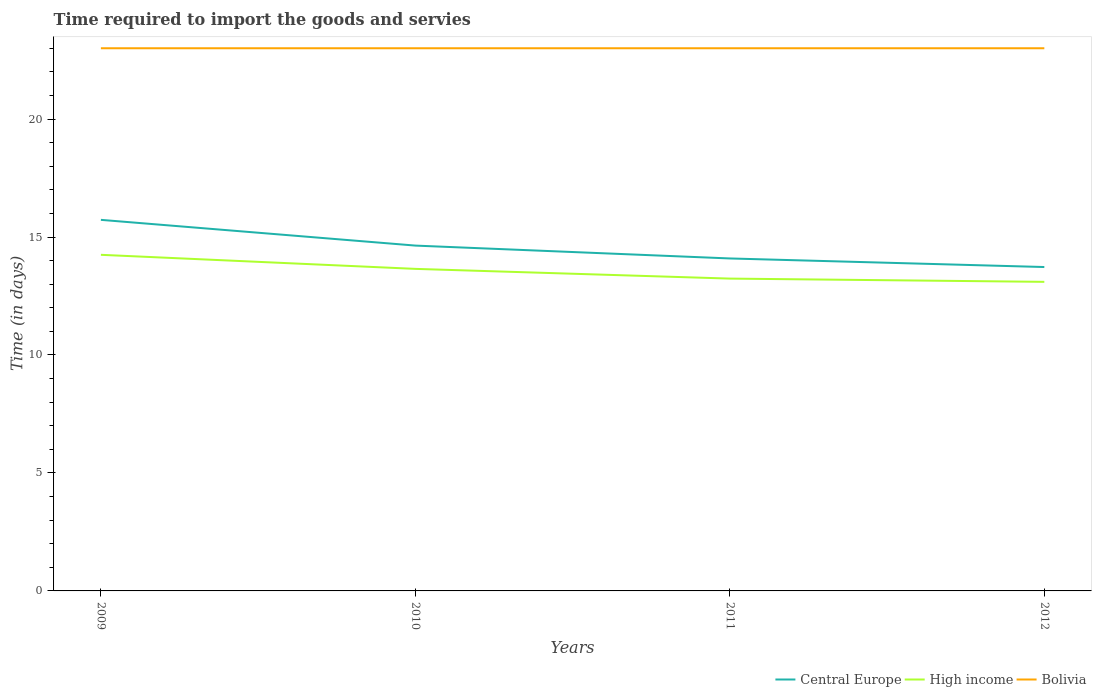How many different coloured lines are there?
Provide a short and direct response. 3. Does the line corresponding to Bolivia intersect with the line corresponding to High income?
Your answer should be compact. No. Across all years, what is the maximum number of days required to import the goods and services in Bolivia?
Make the answer very short. 23. In which year was the number of days required to import the goods and services in Bolivia maximum?
Keep it short and to the point. 2009. What is the total number of days required to import the goods and services in Central Europe in the graph?
Your response must be concise. 1.09. What is the difference between the highest and the second highest number of days required to import the goods and services in Bolivia?
Offer a very short reply. 0. How many years are there in the graph?
Offer a very short reply. 4. Are the values on the major ticks of Y-axis written in scientific E-notation?
Make the answer very short. No. Does the graph contain grids?
Offer a terse response. No. Where does the legend appear in the graph?
Give a very brief answer. Bottom right. How many legend labels are there?
Offer a very short reply. 3. How are the legend labels stacked?
Offer a terse response. Horizontal. What is the title of the graph?
Your answer should be very brief. Time required to import the goods and servies. Does "Malta" appear as one of the legend labels in the graph?
Offer a very short reply. No. What is the label or title of the X-axis?
Offer a very short reply. Years. What is the label or title of the Y-axis?
Your answer should be compact. Time (in days). What is the Time (in days) of Central Europe in 2009?
Provide a short and direct response. 15.73. What is the Time (in days) in High income in 2009?
Provide a short and direct response. 14.25. What is the Time (in days) in Central Europe in 2010?
Provide a succinct answer. 14.64. What is the Time (in days) in High income in 2010?
Your response must be concise. 13.65. What is the Time (in days) of Bolivia in 2010?
Offer a terse response. 23. What is the Time (in days) of Central Europe in 2011?
Your response must be concise. 14.09. What is the Time (in days) in High income in 2011?
Give a very brief answer. 13.24. What is the Time (in days) in Central Europe in 2012?
Offer a very short reply. 13.73. What is the Time (in days) in High income in 2012?
Keep it short and to the point. 13.1. What is the Time (in days) in Bolivia in 2012?
Keep it short and to the point. 23. Across all years, what is the maximum Time (in days) of Central Europe?
Give a very brief answer. 15.73. Across all years, what is the maximum Time (in days) of High income?
Provide a succinct answer. 14.25. Across all years, what is the minimum Time (in days) in Central Europe?
Offer a very short reply. 13.73. Across all years, what is the minimum Time (in days) of Bolivia?
Your answer should be compact. 23. What is the total Time (in days) in Central Europe in the graph?
Give a very brief answer. 58.18. What is the total Time (in days) in High income in the graph?
Make the answer very short. 54.23. What is the total Time (in days) in Bolivia in the graph?
Give a very brief answer. 92. What is the difference between the Time (in days) in Central Europe in 2009 and that in 2010?
Make the answer very short. 1.09. What is the difference between the Time (in days) of High income in 2009 and that in 2010?
Give a very brief answer. 0.6. What is the difference between the Time (in days) in Central Europe in 2009 and that in 2011?
Your answer should be very brief. 1.64. What is the difference between the Time (in days) in High income in 2009 and that in 2011?
Your response must be concise. 1.01. What is the difference between the Time (in days) of High income in 2009 and that in 2012?
Your response must be concise. 1.15. What is the difference between the Time (in days) in Central Europe in 2010 and that in 2011?
Provide a short and direct response. 0.55. What is the difference between the Time (in days) of High income in 2010 and that in 2011?
Keep it short and to the point. 0.41. What is the difference between the Time (in days) of High income in 2010 and that in 2012?
Offer a very short reply. 0.55. What is the difference between the Time (in days) of Central Europe in 2011 and that in 2012?
Ensure brevity in your answer.  0.36. What is the difference between the Time (in days) in High income in 2011 and that in 2012?
Give a very brief answer. 0.14. What is the difference between the Time (in days) of Central Europe in 2009 and the Time (in days) of High income in 2010?
Your answer should be compact. 2.08. What is the difference between the Time (in days) of Central Europe in 2009 and the Time (in days) of Bolivia in 2010?
Offer a terse response. -7.27. What is the difference between the Time (in days) of High income in 2009 and the Time (in days) of Bolivia in 2010?
Offer a very short reply. -8.75. What is the difference between the Time (in days) of Central Europe in 2009 and the Time (in days) of High income in 2011?
Your answer should be compact. 2.49. What is the difference between the Time (in days) in Central Europe in 2009 and the Time (in days) in Bolivia in 2011?
Your response must be concise. -7.27. What is the difference between the Time (in days) of High income in 2009 and the Time (in days) of Bolivia in 2011?
Your answer should be compact. -8.75. What is the difference between the Time (in days) in Central Europe in 2009 and the Time (in days) in High income in 2012?
Give a very brief answer. 2.63. What is the difference between the Time (in days) of Central Europe in 2009 and the Time (in days) of Bolivia in 2012?
Provide a succinct answer. -7.27. What is the difference between the Time (in days) of High income in 2009 and the Time (in days) of Bolivia in 2012?
Offer a terse response. -8.75. What is the difference between the Time (in days) of Central Europe in 2010 and the Time (in days) of High income in 2011?
Your response must be concise. 1.4. What is the difference between the Time (in days) in Central Europe in 2010 and the Time (in days) in Bolivia in 2011?
Offer a very short reply. -8.36. What is the difference between the Time (in days) in High income in 2010 and the Time (in days) in Bolivia in 2011?
Offer a very short reply. -9.35. What is the difference between the Time (in days) in Central Europe in 2010 and the Time (in days) in High income in 2012?
Provide a short and direct response. 1.54. What is the difference between the Time (in days) in Central Europe in 2010 and the Time (in days) in Bolivia in 2012?
Your answer should be very brief. -8.36. What is the difference between the Time (in days) in High income in 2010 and the Time (in days) in Bolivia in 2012?
Your response must be concise. -9.35. What is the difference between the Time (in days) in Central Europe in 2011 and the Time (in days) in High income in 2012?
Your answer should be compact. 0.99. What is the difference between the Time (in days) in Central Europe in 2011 and the Time (in days) in Bolivia in 2012?
Ensure brevity in your answer.  -8.91. What is the difference between the Time (in days) in High income in 2011 and the Time (in days) in Bolivia in 2012?
Offer a terse response. -9.76. What is the average Time (in days) in Central Europe per year?
Make the answer very short. 14.55. What is the average Time (in days) of High income per year?
Your answer should be compact. 13.56. What is the average Time (in days) of Bolivia per year?
Provide a succinct answer. 23. In the year 2009, what is the difference between the Time (in days) in Central Europe and Time (in days) in High income?
Provide a short and direct response. 1.48. In the year 2009, what is the difference between the Time (in days) in Central Europe and Time (in days) in Bolivia?
Your response must be concise. -7.27. In the year 2009, what is the difference between the Time (in days) of High income and Time (in days) of Bolivia?
Make the answer very short. -8.75. In the year 2010, what is the difference between the Time (in days) in Central Europe and Time (in days) in High income?
Your answer should be very brief. 0.99. In the year 2010, what is the difference between the Time (in days) of Central Europe and Time (in days) of Bolivia?
Make the answer very short. -8.36. In the year 2010, what is the difference between the Time (in days) in High income and Time (in days) in Bolivia?
Your response must be concise. -9.35. In the year 2011, what is the difference between the Time (in days) in Central Europe and Time (in days) in High income?
Your answer should be compact. 0.85. In the year 2011, what is the difference between the Time (in days) of Central Europe and Time (in days) of Bolivia?
Keep it short and to the point. -8.91. In the year 2011, what is the difference between the Time (in days) of High income and Time (in days) of Bolivia?
Provide a succinct answer. -9.76. In the year 2012, what is the difference between the Time (in days) of Central Europe and Time (in days) of High income?
Ensure brevity in your answer.  0.63. In the year 2012, what is the difference between the Time (in days) in Central Europe and Time (in days) in Bolivia?
Offer a very short reply. -9.27. What is the ratio of the Time (in days) of Central Europe in 2009 to that in 2010?
Make the answer very short. 1.07. What is the ratio of the Time (in days) in High income in 2009 to that in 2010?
Offer a terse response. 1.04. What is the ratio of the Time (in days) in Central Europe in 2009 to that in 2011?
Provide a short and direct response. 1.12. What is the ratio of the Time (in days) of High income in 2009 to that in 2011?
Offer a very short reply. 1.08. What is the ratio of the Time (in days) in Bolivia in 2009 to that in 2011?
Offer a terse response. 1. What is the ratio of the Time (in days) in Central Europe in 2009 to that in 2012?
Ensure brevity in your answer.  1.15. What is the ratio of the Time (in days) of High income in 2009 to that in 2012?
Provide a short and direct response. 1.09. What is the ratio of the Time (in days) in Bolivia in 2009 to that in 2012?
Ensure brevity in your answer.  1. What is the ratio of the Time (in days) of Central Europe in 2010 to that in 2011?
Your response must be concise. 1.04. What is the ratio of the Time (in days) of High income in 2010 to that in 2011?
Offer a very short reply. 1.03. What is the ratio of the Time (in days) of Bolivia in 2010 to that in 2011?
Keep it short and to the point. 1. What is the ratio of the Time (in days) in Central Europe in 2010 to that in 2012?
Keep it short and to the point. 1.07. What is the ratio of the Time (in days) of High income in 2010 to that in 2012?
Ensure brevity in your answer.  1.04. What is the ratio of the Time (in days) of Central Europe in 2011 to that in 2012?
Ensure brevity in your answer.  1.03. What is the ratio of the Time (in days) of High income in 2011 to that in 2012?
Your response must be concise. 1.01. What is the ratio of the Time (in days) of Bolivia in 2011 to that in 2012?
Your answer should be very brief. 1. What is the difference between the highest and the second highest Time (in days) in Central Europe?
Your response must be concise. 1.09. What is the difference between the highest and the second highest Time (in days) of High income?
Give a very brief answer. 0.6. What is the difference between the highest and the second highest Time (in days) in Bolivia?
Keep it short and to the point. 0. What is the difference between the highest and the lowest Time (in days) of High income?
Your response must be concise. 1.15. 